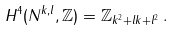<formula> <loc_0><loc_0><loc_500><loc_500>H ^ { 4 } ( N ^ { k , l } , \mathbb { Z } ) = \mathbb { Z } _ { k ^ { 2 } + l k + l ^ { 2 } } \, .</formula> 